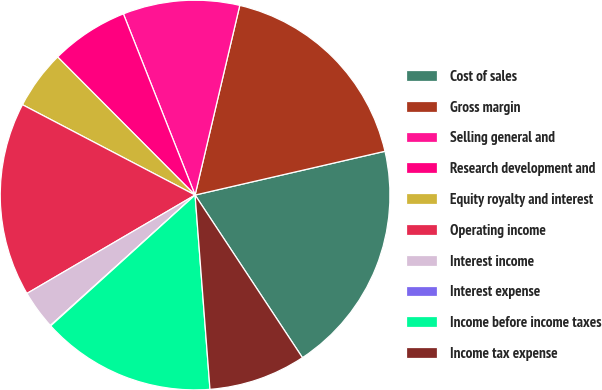Convert chart. <chart><loc_0><loc_0><loc_500><loc_500><pie_chart><fcel>Cost of sales<fcel>Gross margin<fcel>Selling general and<fcel>Research development and<fcel>Equity royalty and interest<fcel>Operating income<fcel>Interest income<fcel>Interest expense<fcel>Income before income taxes<fcel>Income tax expense<nl><fcel>19.32%<fcel>17.71%<fcel>9.68%<fcel>6.47%<fcel>4.86%<fcel>16.1%<fcel>3.25%<fcel>0.04%<fcel>14.5%<fcel>8.07%<nl></chart> 